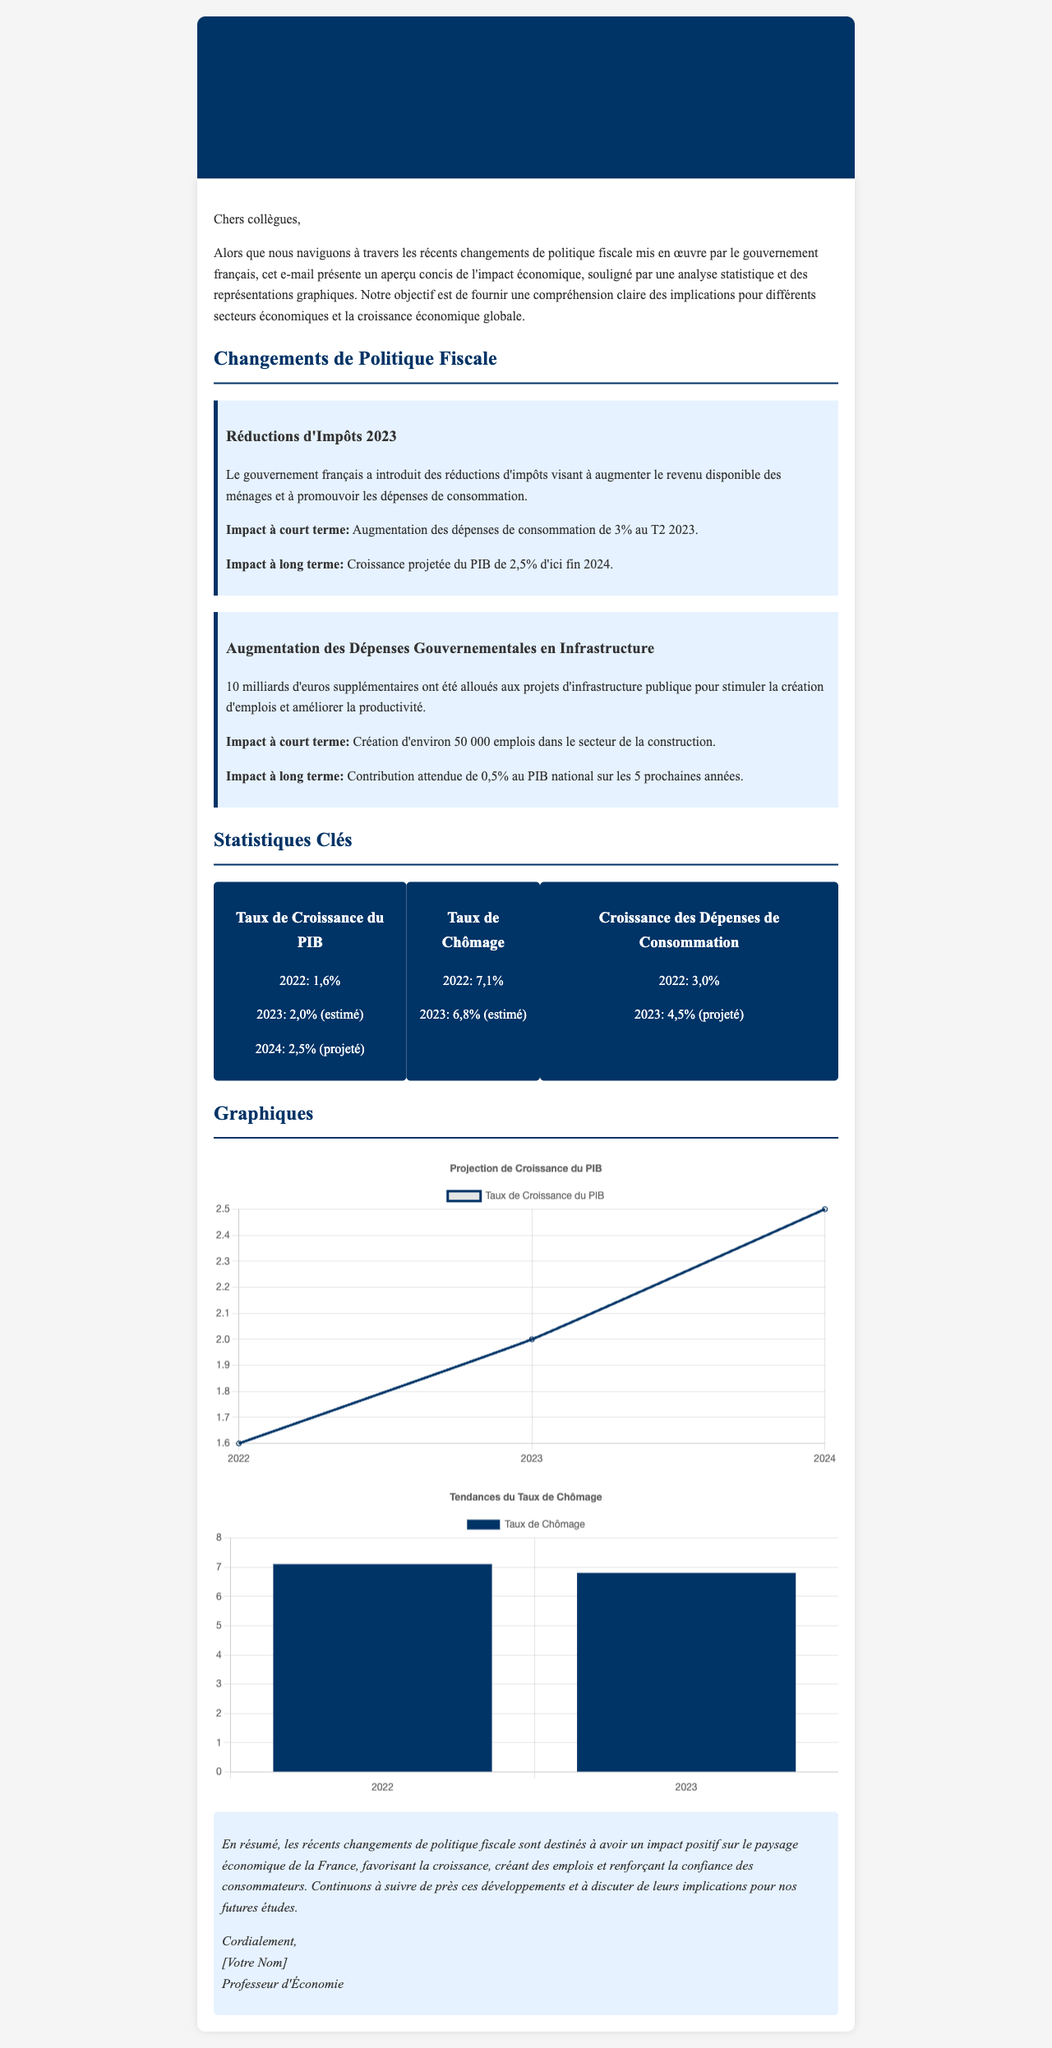Quel est le taux de croissance du PIB pour 2024 ? Le taux de croissance du PIB pour 2024 est mentionné comme 2,5% dans le document.
Answer: 2,5% Quel est l'impact à court terme des réductions d'impôts ? L'impact à court terme des réductions d'impôts est une augmentation des dépenses de consommation de 3% au T2 2023.
Answer: 3% Combien d'euros ont été alloués aux projets d'infrastructure publique ? Le document indique que 10 milliards d'euros ont été alloués aux projets d'infrastructure publique.
Answer: 10 milliards d'euros Quel est le taux de chômage estimé pour 2023 ? Le taux de chômage estimé pour 2023 est mentionné comme 6,8% dans le rapport.
Answer: 6,8% Quel est le nombre d'emplois créé dans le secteur de la construction ? Environ 50 000 emplois ont été créés dans le secteur de la construction selon le document.
Answer: 50 000 emplois Quelle est la croissance projetée des dépenses de consommation pour 2023 ? La croissance projetée des dépenses de consommation pour 2023 est de 4,5% selon le rapport.
Answer: 4,5% Quel type de document est présenté ici ? Le document est un rapport d'impact économique sur les changements de politique fiscale.
Answer: Rapport d'impact économique Quel est l'objectif principal de ce rapport ? L'objectif principal de ce rapport est de fournir une compréhension claire des implications des changements de politique fiscale sur l'économie.
Answer: Compréhension claire des implications 